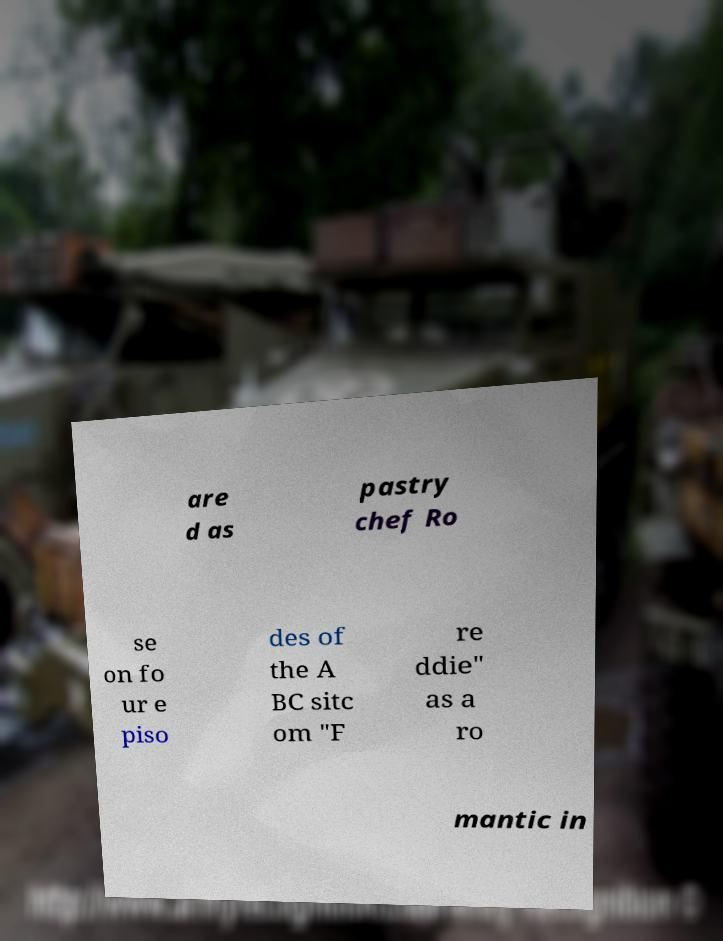For documentation purposes, I need the text within this image transcribed. Could you provide that? are d as pastry chef Ro se on fo ur e piso des of the A BC sitc om "F re ddie" as a ro mantic in 